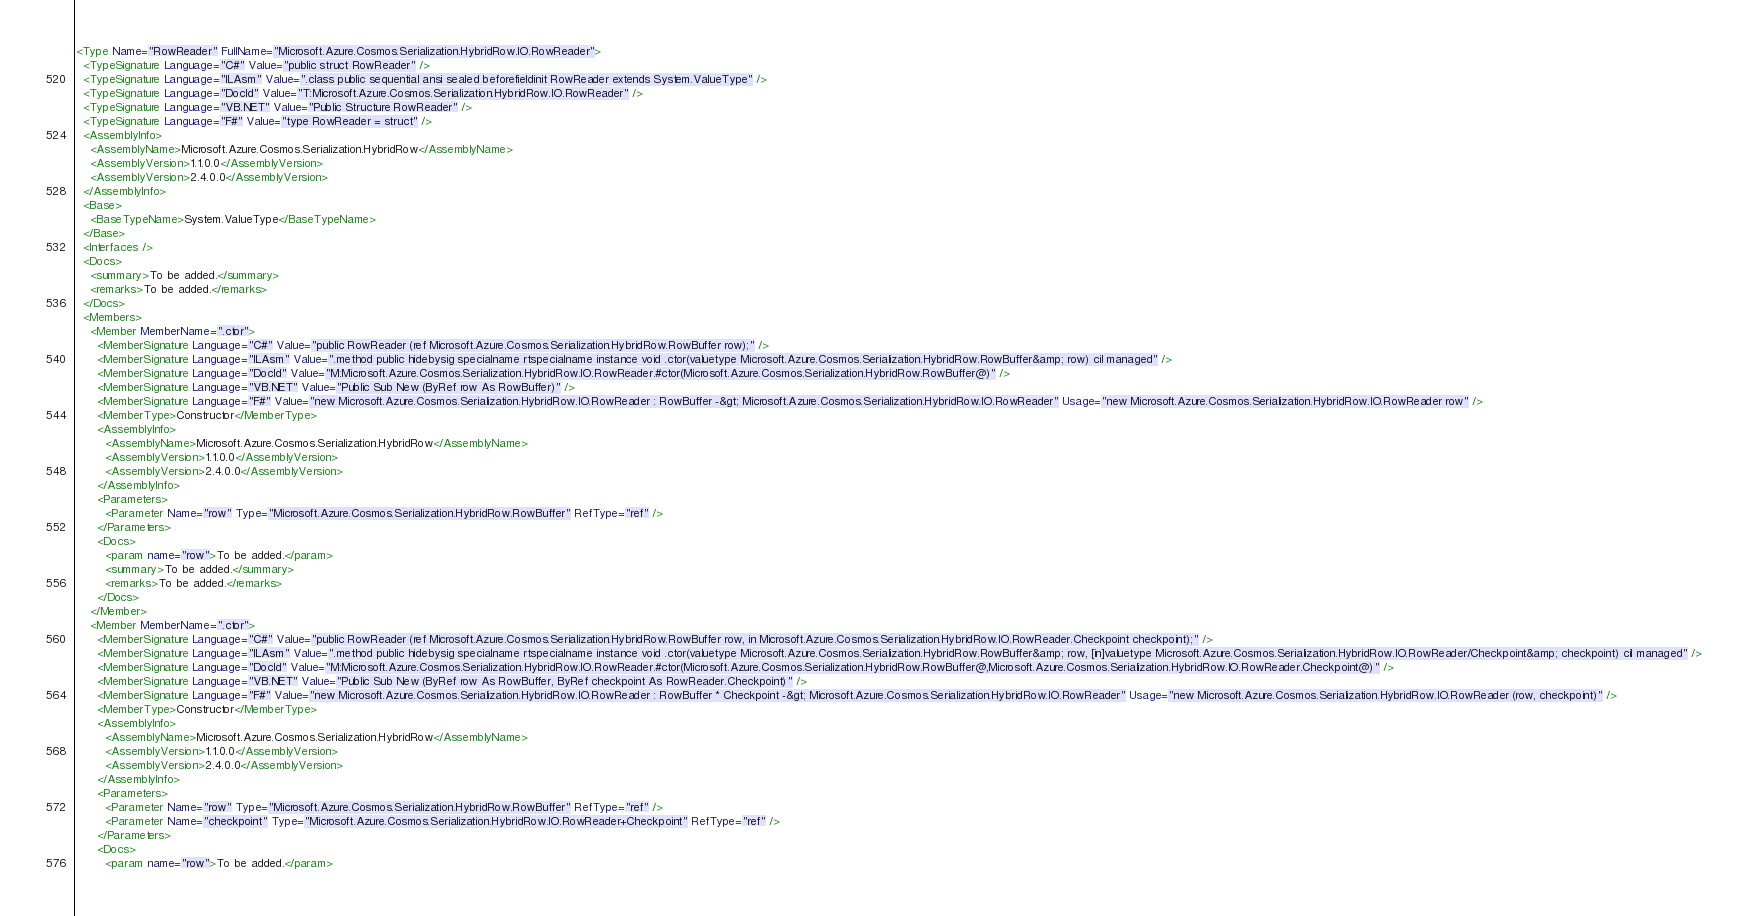<code> <loc_0><loc_0><loc_500><loc_500><_XML_><Type Name="RowReader" FullName="Microsoft.Azure.Cosmos.Serialization.HybridRow.IO.RowReader">
  <TypeSignature Language="C#" Value="public struct RowReader" />
  <TypeSignature Language="ILAsm" Value=".class public sequential ansi sealed beforefieldinit RowReader extends System.ValueType" />
  <TypeSignature Language="DocId" Value="T:Microsoft.Azure.Cosmos.Serialization.HybridRow.IO.RowReader" />
  <TypeSignature Language="VB.NET" Value="Public Structure RowReader" />
  <TypeSignature Language="F#" Value="type RowReader = struct" />
  <AssemblyInfo>
    <AssemblyName>Microsoft.Azure.Cosmos.Serialization.HybridRow</AssemblyName>
    <AssemblyVersion>1.1.0.0</AssemblyVersion>
    <AssemblyVersion>2.4.0.0</AssemblyVersion>
  </AssemblyInfo>
  <Base>
    <BaseTypeName>System.ValueType</BaseTypeName>
  </Base>
  <Interfaces />
  <Docs>
    <summary>To be added.</summary>
    <remarks>To be added.</remarks>
  </Docs>
  <Members>
    <Member MemberName=".ctor">
      <MemberSignature Language="C#" Value="public RowReader (ref Microsoft.Azure.Cosmos.Serialization.HybridRow.RowBuffer row);" />
      <MemberSignature Language="ILAsm" Value=".method public hidebysig specialname rtspecialname instance void .ctor(valuetype Microsoft.Azure.Cosmos.Serialization.HybridRow.RowBuffer&amp; row) cil managed" />
      <MemberSignature Language="DocId" Value="M:Microsoft.Azure.Cosmos.Serialization.HybridRow.IO.RowReader.#ctor(Microsoft.Azure.Cosmos.Serialization.HybridRow.RowBuffer@)" />
      <MemberSignature Language="VB.NET" Value="Public Sub New (ByRef row As RowBuffer)" />
      <MemberSignature Language="F#" Value="new Microsoft.Azure.Cosmos.Serialization.HybridRow.IO.RowReader : RowBuffer -&gt; Microsoft.Azure.Cosmos.Serialization.HybridRow.IO.RowReader" Usage="new Microsoft.Azure.Cosmos.Serialization.HybridRow.IO.RowReader row" />
      <MemberType>Constructor</MemberType>
      <AssemblyInfo>
        <AssemblyName>Microsoft.Azure.Cosmos.Serialization.HybridRow</AssemblyName>
        <AssemblyVersion>1.1.0.0</AssemblyVersion>
        <AssemblyVersion>2.4.0.0</AssemblyVersion>
      </AssemblyInfo>
      <Parameters>
        <Parameter Name="row" Type="Microsoft.Azure.Cosmos.Serialization.HybridRow.RowBuffer" RefType="ref" />
      </Parameters>
      <Docs>
        <param name="row">To be added.</param>
        <summary>To be added.</summary>
        <remarks>To be added.</remarks>
      </Docs>
    </Member>
    <Member MemberName=".ctor">
      <MemberSignature Language="C#" Value="public RowReader (ref Microsoft.Azure.Cosmos.Serialization.HybridRow.RowBuffer row, in Microsoft.Azure.Cosmos.Serialization.HybridRow.IO.RowReader.Checkpoint checkpoint);" />
      <MemberSignature Language="ILAsm" Value=".method public hidebysig specialname rtspecialname instance void .ctor(valuetype Microsoft.Azure.Cosmos.Serialization.HybridRow.RowBuffer&amp; row, [in]valuetype Microsoft.Azure.Cosmos.Serialization.HybridRow.IO.RowReader/Checkpoint&amp; checkpoint) cil managed" />
      <MemberSignature Language="DocId" Value="M:Microsoft.Azure.Cosmos.Serialization.HybridRow.IO.RowReader.#ctor(Microsoft.Azure.Cosmos.Serialization.HybridRow.RowBuffer@,Microsoft.Azure.Cosmos.Serialization.HybridRow.IO.RowReader.Checkpoint@)" />
      <MemberSignature Language="VB.NET" Value="Public Sub New (ByRef row As RowBuffer, ByRef checkpoint As RowReader.Checkpoint)" />
      <MemberSignature Language="F#" Value="new Microsoft.Azure.Cosmos.Serialization.HybridRow.IO.RowReader : RowBuffer * Checkpoint -&gt; Microsoft.Azure.Cosmos.Serialization.HybridRow.IO.RowReader" Usage="new Microsoft.Azure.Cosmos.Serialization.HybridRow.IO.RowReader (row, checkpoint)" />
      <MemberType>Constructor</MemberType>
      <AssemblyInfo>
        <AssemblyName>Microsoft.Azure.Cosmos.Serialization.HybridRow</AssemblyName>
        <AssemblyVersion>1.1.0.0</AssemblyVersion>
        <AssemblyVersion>2.4.0.0</AssemblyVersion>
      </AssemblyInfo>
      <Parameters>
        <Parameter Name="row" Type="Microsoft.Azure.Cosmos.Serialization.HybridRow.RowBuffer" RefType="ref" />
        <Parameter Name="checkpoint" Type="Microsoft.Azure.Cosmos.Serialization.HybridRow.IO.RowReader+Checkpoint" RefType="ref" />
      </Parameters>
      <Docs>
        <param name="row">To be added.</param></code> 